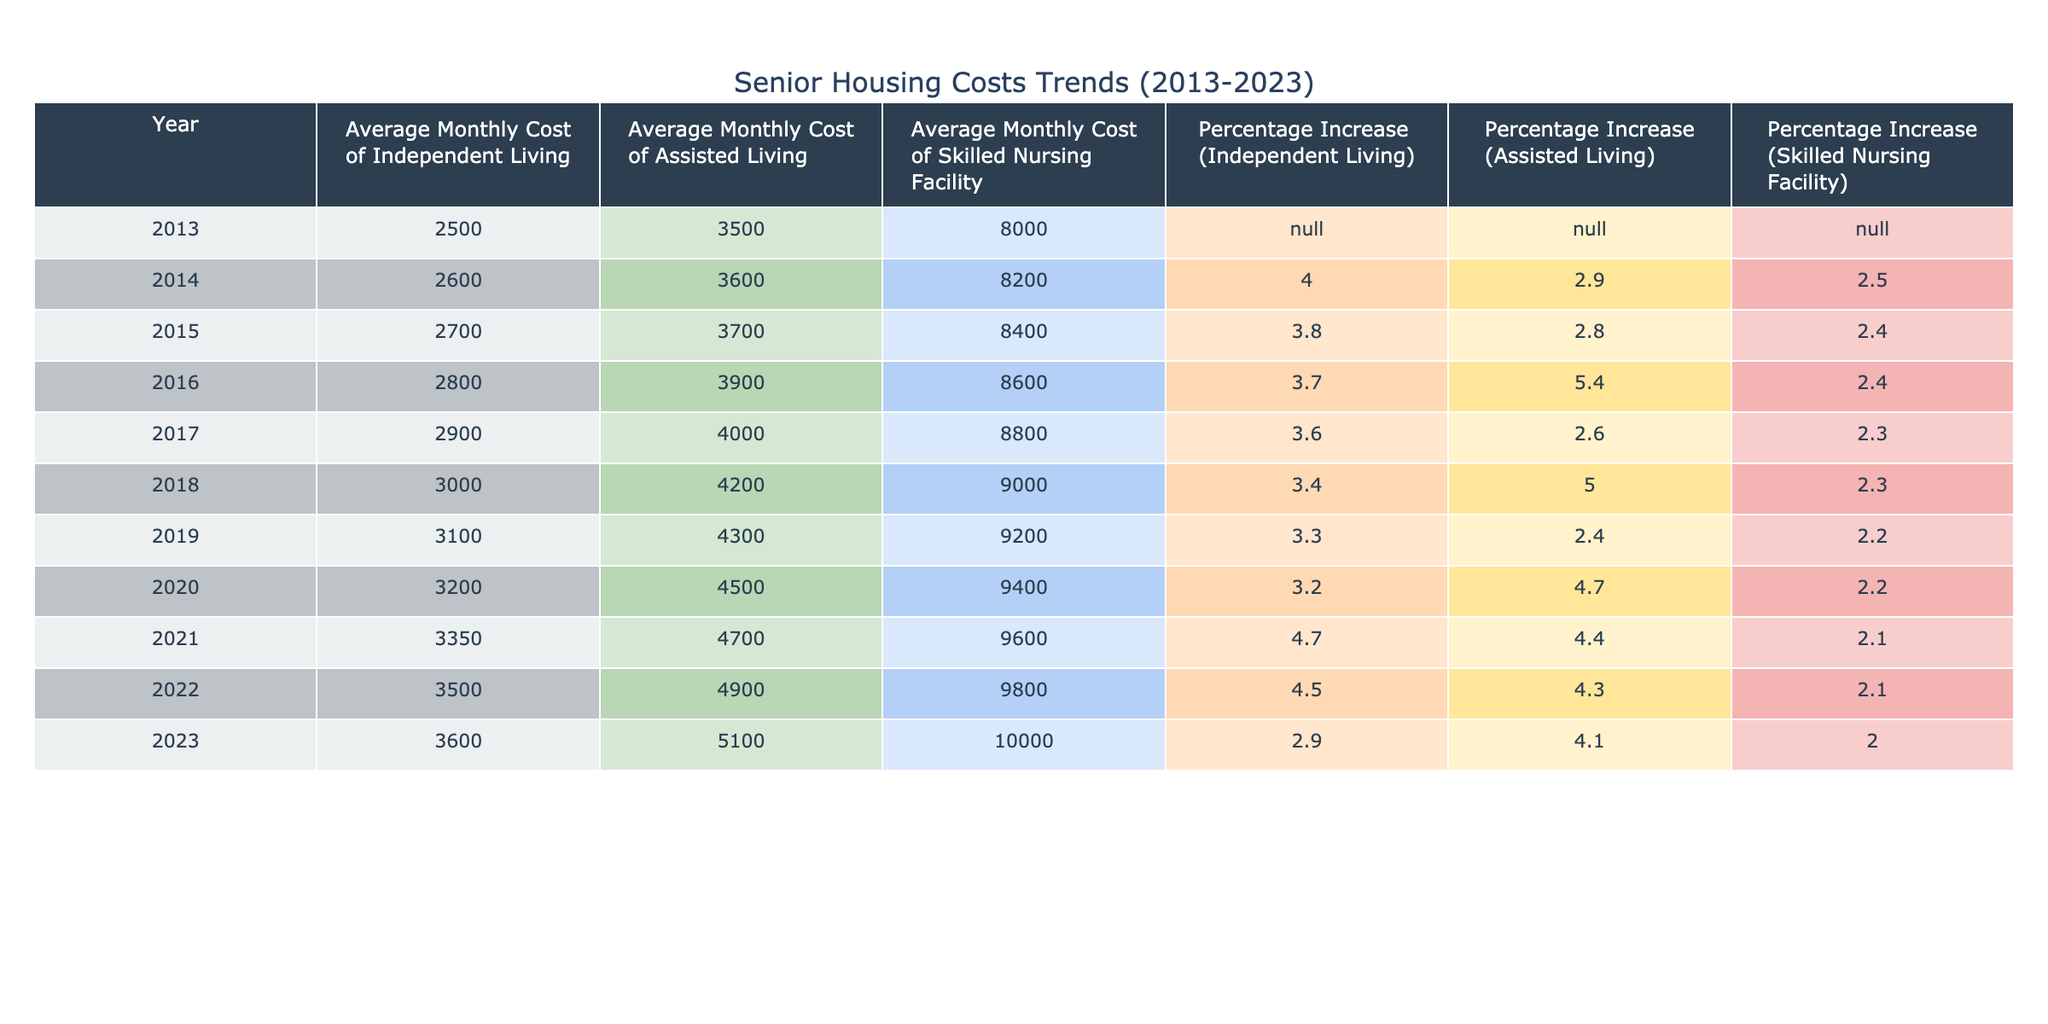What was the average monthly cost of independent living in 2020? The average monthly cost of independent living for 2020 is found in the corresponding row for that year. Looking at the table, the cost listed under the "Average Monthly Cost of Independent Living" column for 2020 is 3200.
Answer: 3200 What percentage increase did assisted living costs experience from 2014 to 2020? To find the percentage increase from 2014 to 2020, we look at the "Percentage Increase (Assisted Living)" column for both years. The increase in 2014 was 2.9% and in 2020 was 4.7%. Now, we find the difference: 4.7% - 2.9% = 1.8%.
Answer: 1.8% Was there a year when the average monthly cost of a skilled nursing facility decreased? Upon inspecting the "Average Monthly Cost of Skilled Nursing Facility" column, we see the values for each year, and none of the recorded costs show a decrease; they consistently increase from 8000 in 2013 to 10000 in 2023. Therefore, the answer is no.
Answer: No How much did the average monthly cost of independent living increase from 2013 to 2023? We start with the value of average monthly cost of independent living in 2013, which is 2500, and the value in 2023, which is 3600. To find the increase, we subtract: 3600 - 2500 = 1100.
Answer: 1100 What was the highest average monthly cost of assisted living recorded in the table and in which year? By scanning the column for "Average Monthly Cost of Assisted Living," we look for the highest value. The maximum is 5100 in 2023.
Answer: 5100 in 2023 What is the difference in average monthly costs between independent living and assisted living in 2016? For 2016, the average monthly cost of independent living is 2800 and for assisted living it is 3900. We calculate the difference by subtracting the two costs: 3900 - 2800 = 1100.
Answer: 1100 In which year did the average monthly cost of skilled nursing facilities increase the least? We will need to examine the "Percentage Increase (Skilled Nursing Facility)" column to identify the smallest increase over the years. The lowest percentage is 2.0% in 2023, meaning that 2023 saw the least increase.
Answer: 2023 Is the average cost of assisted living higher in 2022 than in 2019? Looking at the two years, the average monthly cost for assisted living in 2019 is 4300, while in 2022 it is 4900. Since 4900 is greater than 4300, this statement is true.
Answer: Yes 